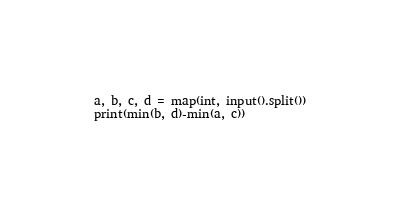Convert code to text. <code><loc_0><loc_0><loc_500><loc_500><_Python_>a, b, c, d = map(int, input().split())
print(min(b, d)-min(a, c))
</code> 